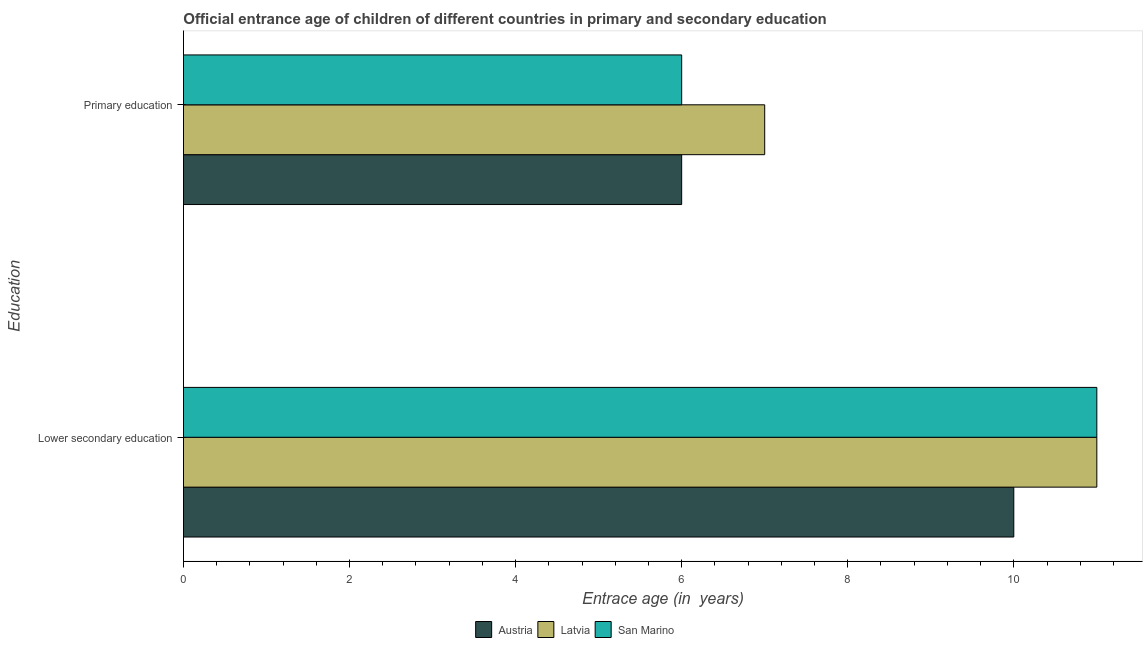How many groups of bars are there?
Your answer should be very brief. 2. How many bars are there on the 2nd tick from the bottom?
Offer a very short reply. 3. What is the label of the 2nd group of bars from the top?
Offer a very short reply. Lower secondary education. What is the entrance age of chiildren in primary education in Latvia?
Keep it short and to the point. 7. Across all countries, what is the maximum entrance age of children in lower secondary education?
Offer a terse response. 11. In which country was the entrance age of children in lower secondary education maximum?
Offer a terse response. Latvia. What is the total entrance age of children in lower secondary education in the graph?
Your response must be concise. 32. What is the difference between the entrance age of chiildren in primary education in Austria and that in Latvia?
Ensure brevity in your answer.  -1. What is the difference between the entrance age of chiildren in primary education in Austria and the entrance age of children in lower secondary education in San Marino?
Keep it short and to the point. -5. What is the average entrance age of chiildren in primary education per country?
Your answer should be very brief. 6.33. What is the difference between the entrance age of chiildren in primary education and entrance age of children in lower secondary education in San Marino?
Ensure brevity in your answer.  -5. What is the ratio of the entrance age of chiildren in primary education in San Marino to that in Austria?
Your answer should be very brief. 1. Is the entrance age of children in lower secondary education in Latvia less than that in San Marino?
Provide a short and direct response. No. In how many countries, is the entrance age of chiildren in primary education greater than the average entrance age of chiildren in primary education taken over all countries?
Keep it short and to the point. 1. What does the 3rd bar from the bottom in Lower secondary education represents?
Your answer should be compact. San Marino. Are the values on the major ticks of X-axis written in scientific E-notation?
Provide a short and direct response. No. Does the graph contain grids?
Offer a terse response. No. Where does the legend appear in the graph?
Your response must be concise. Bottom center. How many legend labels are there?
Ensure brevity in your answer.  3. How are the legend labels stacked?
Provide a short and direct response. Horizontal. What is the title of the graph?
Provide a succinct answer. Official entrance age of children of different countries in primary and secondary education. Does "Mongolia" appear as one of the legend labels in the graph?
Make the answer very short. No. What is the label or title of the X-axis?
Give a very brief answer. Entrace age (in  years). What is the label or title of the Y-axis?
Give a very brief answer. Education. What is the Entrace age (in  years) in Latvia in Lower secondary education?
Provide a succinct answer. 11. What is the Entrace age (in  years) in Austria in Primary education?
Make the answer very short. 6. What is the Entrace age (in  years) of Latvia in Primary education?
Offer a terse response. 7. Across all Education, what is the maximum Entrace age (in  years) of Latvia?
Offer a terse response. 11. Across all Education, what is the maximum Entrace age (in  years) of San Marino?
Offer a very short reply. 11. Across all Education, what is the minimum Entrace age (in  years) of Austria?
Your answer should be compact. 6. Across all Education, what is the minimum Entrace age (in  years) of Latvia?
Make the answer very short. 7. Across all Education, what is the minimum Entrace age (in  years) of San Marino?
Offer a terse response. 6. What is the difference between the Entrace age (in  years) in Austria in Lower secondary education and that in Primary education?
Ensure brevity in your answer.  4. What is the difference between the Entrace age (in  years) of Latvia in Lower secondary education and that in Primary education?
Give a very brief answer. 4. What is the difference between the Entrace age (in  years) in Austria in Lower secondary education and the Entrace age (in  years) in Latvia in Primary education?
Offer a terse response. 3. What is the difference between the Entrace age (in  years) of Austria and Entrace age (in  years) of Latvia in Lower secondary education?
Make the answer very short. -1. What is the difference between the Entrace age (in  years) of Latvia and Entrace age (in  years) of San Marino in Lower secondary education?
Offer a terse response. 0. What is the difference between the Entrace age (in  years) of Austria and Entrace age (in  years) of Latvia in Primary education?
Make the answer very short. -1. What is the difference between the Entrace age (in  years) in Latvia and Entrace age (in  years) in San Marino in Primary education?
Offer a terse response. 1. What is the ratio of the Entrace age (in  years) of Latvia in Lower secondary education to that in Primary education?
Offer a terse response. 1.57. What is the ratio of the Entrace age (in  years) in San Marino in Lower secondary education to that in Primary education?
Ensure brevity in your answer.  1.83. What is the difference between the highest and the second highest Entrace age (in  years) in Austria?
Ensure brevity in your answer.  4. What is the difference between the highest and the second highest Entrace age (in  years) of Latvia?
Your answer should be very brief. 4. What is the difference between the highest and the lowest Entrace age (in  years) in Austria?
Your response must be concise. 4. What is the difference between the highest and the lowest Entrace age (in  years) in San Marino?
Give a very brief answer. 5. 